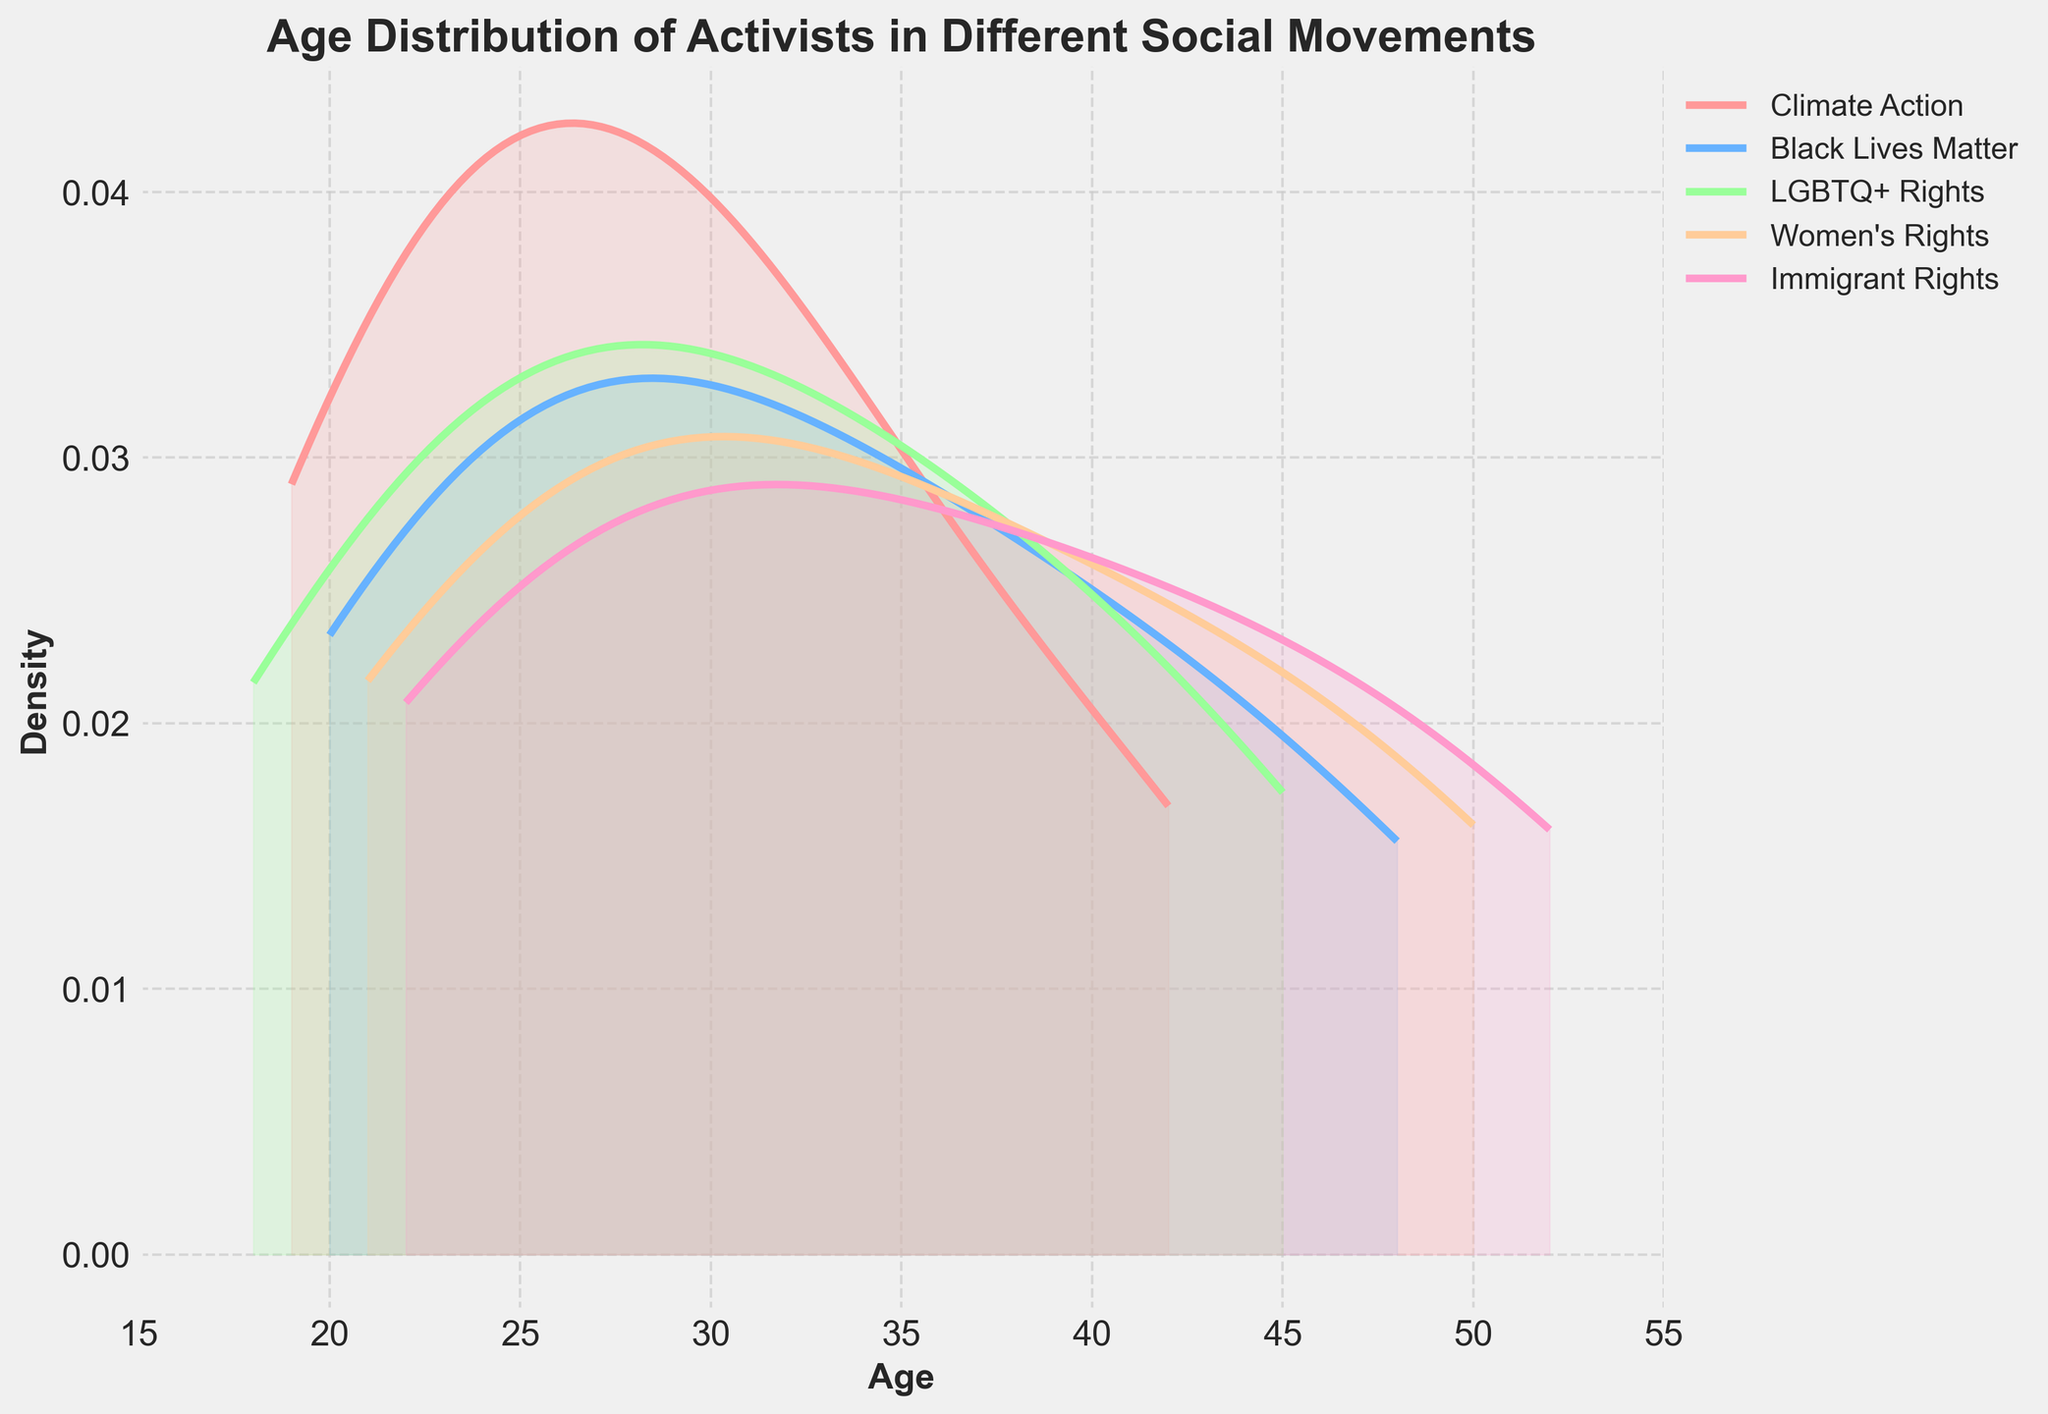What is the title of the plot? The title of the plot is displayed at the top of the figure.
Answer: Age Distribution of Activists in Different Social Movements What is the age range shown on the x-axis? The age range on the x-axis goes from 15 to 55, as indicated by the axis labels.
Answer: 15 to 55 Which social movement has the youngest age density peak? By visually inspecting the density plot, the 'Climate Action' movement shows a peak density at a younger age compared to other movements.
Answer: Climate Action Which social movement has the broadest age distribution? The 'Immigrant Rights' movement shows a broader spread in the density plot, indicating a wider age distribution of activists.
Answer: Immigrant Rights In which social movement do the activists' ages cluster most closely around the middle age? The 'Women's Rights' density plot shows the highest density clustering around the middle ages (early 30s).
Answer: Women's Rights Which two movements have the most similar age distribution? By comparing the density curves, 'Black Lives Matter' and 'LGBTQ+ Rights' have the most similar age distribution patterns.
Answer: Black Lives Matter and LGBTQ+ Rights Which movement has the least density of young activists (ages 15-25)? Inspecting the density plot, the 'Immigrant Rights' movement has the least density in the 15-25 age range.
Answer: Immigrant Rights How does the peak density of 'Climate Action' compare to 'Women's Rights'? 'Climate Action' has a peak density at a younger age, while 'Women's Rights' peaks around middle age. This visual cue from the plot indicates a significant difference in the age group concentration.
Answer: Younger for Climate Action, Middle Age for Women's Rights 